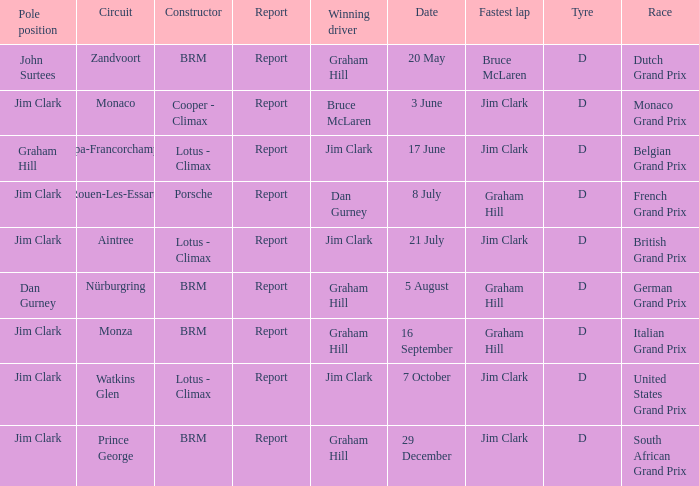What is the date of the circuit of nürburgring, which had Graham Hill as the winning driver? 5 August. 